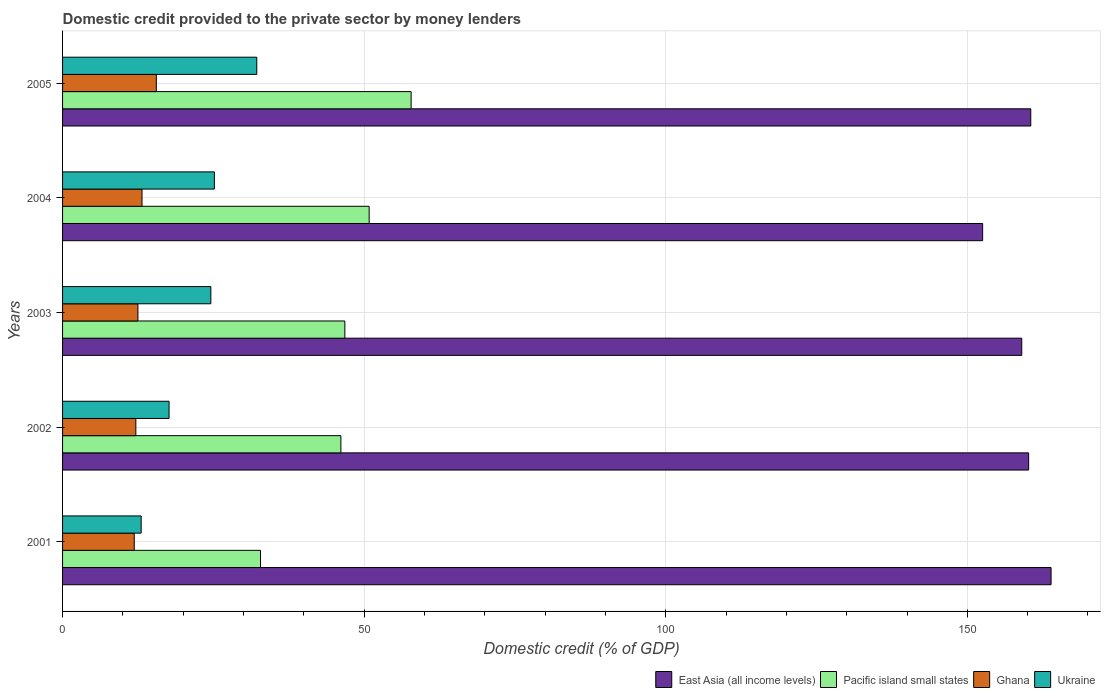How many different coloured bars are there?
Ensure brevity in your answer.  4. How many groups of bars are there?
Offer a terse response. 5. Are the number of bars per tick equal to the number of legend labels?
Ensure brevity in your answer.  Yes. How many bars are there on the 1st tick from the top?
Offer a very short reply. 4. How many bars are there on the 4th tick from the bottom?
Ensure brevity in your answer.  4. What is the label of the 2nd group of bars from the top?
Provide a short and direct response. 2004. In how many cases, is the number of bars for a given year not equal to the number of legend labels?
Your answer should be very brief. 0. What is the domestic credit provided to the private sector by money lenders in Pacific island small states in 2002?
Offer a terse response. 46.14. Across all years, what is the maximum domestic credit provided to the private sector by money lenders in Ghana?
Ensure brevity in your answer.  15.54. Across all years, what is the minimum domestic credit provided to the private sector by money lenders in Ukraine?
Keep it short and to the point. 13.03. In which year was the domestic credit provided to the private sector by money lenders in Pacific island small states minimum?
Your answer should be compact. 2001. What is the total domestic credit provided to the private sector by money lenders in East Asia (all income levels) in the graph?
Keep it short and to the point. 796.12. What is the difference between the domestic credit provided to the private sector by money lenders in Ghana in 2001 and that in 2005?
Offer a very short reply. -3.66. What is the difference between the domestic credit provided to the private sector by money lenders in Ghana in 2003 and the domestic credit provided to the private sector by money lenders in Ukraine in 2002?
Your answer should be very brief. -5.16. What is the average domestic credit provided to the private sector by money lenders in Ghana per year?
Make the answer very short. 13.05. In the year 2002, what is the difference between the domestic credit provided to the private sector by money lenders in Ukraine and domestic credit provided to the private sector by money lenders in Ghana?
Make the answer very short. 5.51. What is the ratio of the domestic credit provided to the private sector by money lenders in Ukraine in 2001 to that in 2003?
Your answer should be compact. 0.53. Is the domestic credit provided to the private sector by money lenders in Pacific island small states in 2002 less than that in 2004?
Keep it short and to the point. Yes. What is the difference between the highest and the second highest domestic credit provided to the private sector by money lenders in Ghana?
Offer a terse response. 2.37. What is the difference between the highest and the lowest domestic credit provided to the private sector by money lenders in Ghana?
Offer a terse response. 3.66. In how many years, is the domestic credit provided to the private sector by money lenders in Pacific island small states greater than the average domestic credit provided to the private sector by money lenders in Pacific island small states taken over all years?
Your response must be concise. 2. Is it the case that in every year, the sum of the domestic credit provided to the private sector by money lenders in East Asia (all income levels) and domestic credit provided to the private sector by money lenders in Pacific island small states is greater than the sum of domestic credit provided to the private sector by money lenders in Ukraine and domestic credit provided to the private sector by money lenders in Ghana?
Provide a succinct answer. Yes. What does the 4th bar from the top in 2003 represents?
Offer a very short reply. East Asia (all income levels). What does the 1st bar from the bottom in 2003 represents?
Your answer should be very brief. East Asia (all income levels). Is it the case that in every year, the sum of the domestic credit provided to the private sector by money lenders in Pacific island small states and domestic credit provided to the private sector by money lenders in East Asia (all income levels) is greater than the domestic credit provided to the private sector by money lenders in Ghana?
Make the answer very short. Yes. How many bars are there?
Give a very brief answer. 20. Are the values on the major ticks of X-axis written in scientific E-notation?
Give a very brief answer. No. Does the graph contain any zero values?
Offer a very short reply. No. Where does the legend appear in the graph?
Provide a short and direct response. Bottom right. How many legend labels are there?
Provide a short and direct response. 4. How are the legend labels stacked?
Provide a short and direct response. Horizontal. What is the title of the graph?
Make the answer very short. Domestic credit provided to the private sector by money lenders. What is the label or title of the X-axis?
Your answer should be very brief. Domestic credit (% of GDP). What is the Domestic credit (% of GDP) of East Asia (all income levels) in 2001?
Provide a short and direct response. 163.88. What is the Domestic credit (% of GDP) of Pacific island small states in 2001?
Ensure brevity in your answer.  32.81. What is the Domestic credit (% of GDP) in Ghana in 2001?
Give a very brief answer. 11.88. What is the Domestic credit (% of GDP) of Ukraine in 2001?
Your response must be concise. 13.03. What is the Domestic credit (% of GDP) of East Asia (all income levels) in 2002?
Your answer should be very brief. 160.16. What is the Domestic credit (% of GDP) in Pacific island small states in 2002?
Your answer should be compact. 46.14. What is the Domestic credit (% of GDP) in Ghana in 2002?
Your answer should be very brief. 12.15. What is the Domestic credit (% of GDP) in Ukraine in 2002?
Your response must be concise. 17.65. What is the Domestic credit (% of GDP) of East Asia (all income levels) in 2003?
Ensure brevity in your answer.  159.02. What is the Domestic credit (% of GDP) of Pacific island small states in 2003?
Your response must be concise. 46.8. What is the Domestic credit (% of GDP) of Ghana in 2003?
Make the answer very short. 12.49. What is the Domestic credit (% of GDP) in Ukraine in 2003?
Ensure brevity in your answer.  24.58. What is the Domestic credit (% of GDP) of East Asia (all income levels) in 2004?
Provide a succinct answer. 152.54. What is the Domestic credit (% of GDP) in Pacific island small states in 2004?
Offer a terse response. 50.83. What is the Domestic credit (% of GDP) in Ghana in 2004?
Offer a terse response. 13.17. What is the Domestic credit (% of GDP) of Ukraine in 2004?
Provide a short and direct response. 25.17. What is the Domestic credit (% of GDP) of East Asia (all income levels) in 2005?
Your response must be concise. 160.51. What is the Domestic credit (% of GDP) in Pacific island small states in 2005?
Your answer should be compact. 57.79. What is the Domestic credit (% of GDP) in Ghana in 2005?
Your answer should be compact. 15.54. What is the Domestic credit (% of GDP) in Ukraine in 2005?
Give a very brief answer. 32.2. Across all years, what is the maximum Domestic credit (% of GDP) of East Asia (all income levels)?
Provide a succinct answer. 163.88. Across all years, what is the maximum Domestic credit (% of GDP) in Pacific island small states?
Make the answer very short. 57.79. Across all years, what is the maximum Domestic credit (% of GDP) in Ghana?
Provide a succinct answer. 15.54. Across all years, what is the maximum Domestic credit (% of GDP) in Ukraine?
Give a very brief answer. 32.2. Across all years, what is the minimum Domestic credit (% of GDP) of East Asia (all income levels)?
Provide a succinct answer. 152.54. Across all years, what is the minimum Domestic credit (% of GDP) in Pacific island small states?
Give a very brief answer. 32.81. Across all years, what is the minimum Domestic credit (% of GDP) in Ghana?
Your response must be concise. 11.88. Across all years, what is the minimum Domestic credit (% of GDP) of Ukraine?
Provide a short and direct response. 13.03. What is the total Domestic credit (% of GDP) in East Asia (all income levels) in the graph?
Provide a succinct answer. 796.12. What is the total Domestic credit (% of GDP) of Pacific island small states in the graph?
Your answer should be very brief. 234.37. What is the total Domestic credit (% of GDP) of Ghana in the graph?
Your response must be concise. 65.24. What is the total Domestic credit (% of GDP) of Ukraine in the graph?
Offer a very short reply. 112.63. What is the difference between the Domestic credit (% of GDP) in East Asia (all income levels) in 2001 and that in 2002?
Give a very brief answer. 3.72. What is the difference between the Domestic credit (% of GDP) of Pacific island small states in 2001 and that in 2002?
Your answer should be compact. -13.33. What is the difference between the Domestic credit (% of GDP) of Ghana in 2001 and that in 2002?
Your response must be concise. -0.27. What is the difference between the Domestic credit (% of GDP) in Ukraine in 2001 and that in 2002?
Make the answer very short. -4.63. What is the difference between the Domestic credit (% of GDP) of East Asia (all income levels) in 2001 and that in 2003?
Provide a succinct answer. 4.86. What is the difference between the Domestic credit (% of GDP) of Pacific island small states in 2001 and that in 2003?
Make the answer very short. -13.98. What is the difference between the Domestic credit (% of GDP) in Ghana in 2001 and that in 2003?
Your answer should be very brief. -0.61. What is the difference between the Domestic credit (% of GDP) in Ukraine in 2001 and that in 2003?
Your response must be concise. -11.55. What is the difference between the Domestic credit (% of GDP) in East Asia (all income levels) in 2001 and that in 2004?
Your response must be concise. 11.34. What is the difference between the Domestic credit (% of GDP) in Pacific island small states in 2001 and that in 2004?
Ensure brevity in your answer.  -18.01. What is the difference between the Domestic credit (% of GDP) in Ghana in 2001 and that in 2004?
Offer a very short reply. -1.29. What is the difference between the Domestic credit (% of GDP) of Ukraine in 2001 and that in 2004?
Give a very brief answer. -12.14. What is the difference between the Domestic credit (% of GDP) of East Asia (all income levels) in 2001 and that in 2005?
Offer a very short reply. 3.37. What is the difference between the Domestic credit (% of GDP) in Pacific island small states in 2001 and that in 2005?
Provide a short and direct response. -24.97. What is the difference between the Domestic credit (% of GDP) in Ghana in 2001 and that in 2005?
Offer a very short reply. -3.66. What is the difference between the Domestic credit (% of GDP) in Ukraine in 2001 and that in 2005?
Offer a terse response. -19.17. What is the difference between the Domestic credit (% of GDP) of East Asia (all income levels) in 2002 and that in 2003?
Offer a very short reply. 1.14. What is the difference between the Domestic credit (% of GDP) in Pacific island small states in 2002 and that in 2003?
Offer a terse response. -0.65. What is the difference between the Domestic credit (% of GDP) of Ghana in 2002 and that in 2003?
Your response must be concise. -0.34. What is the difference between the Domestic credit (% of GDP) of Ukraine in 2002 and that in 2003?
Provide a succinct answer. -6.93. What is the difference between the Domestic credit (% of GDP) in East Asia (all income levels) in 2002 and that in 2004?
Offer a terse response. 7.63. What is the difference between the Domestic credit (% of GDP) in Pacific island small states in 2002 and that in 2004?
Offer a terse response. -4.69. What is the difference between the Domestic credit (% of GDP) of Ghana in 2002 and that in 2004?
Provide a short and direct response. -1.02. What is the difference between the Domestic credit (% of GDP) of Ukraine in 2002 and that in 2004?
Offer a terse response. -7.51. What is the difference between the Domestic credit (% of GDP) in East Asia (all income levels) in 2002 and that in 2005?
Offer a terse response. -0.35. What is the difference between the Domestic credit (% of GDP) in Pacific island small states in 2002 and that in 2005?
Your answer should be very brief. -11.64. What is the difference between the Domestic credit (% of GDP) in Ghana in 2002 and that in 2005?
Keep it short and to the point. -3.39. What is the difference between the Domestic credit (% of GDP) in Ukraine in 2002 and that in 2005?
Offer a very short reply. -14.54. What is the difference between the Domestic credit (% of GDP) of East Asia (all income levels) in 2003 and that in 2004?
Your answer should be very brief. 6.48. What is the difference between the Domestic credit (% of GDP) in Pacific island small states in 2003 and that in 2004?
Your answer should be very brief. -4.03. What is the difference between the Domestic credit (% of GDP) in Ghana in 2003 and that in 2004?
Your answer should be compact. -0.68. What is the difference between the Domestic credit (% of GDP) in Ukraine in 2003 and that in 2004?
Your answer should be compact. -0.58. What is the difference between the Domestic credit (% of GDP) of East Asia (all income levels) in 2003 and that in 2005?
Your response must be concise. -1.49. What is the difference between the Domestic credit (% of GDP) of Pacific island small states in 2003 and that in 2005?
Offer a very short reply. -10.99. What is the difference between the Domestic credit (% of GDP) of Ghana in 2003 and that in 2005?
Give a very brief answer. -3.05. What is the difference between the Domestic credit (% of GDP) of Ukraine in 2003 and that in 2005?
Keep it short and to the point. -7.61. What is the difference between the Domestic credit (% of GDP) in East Asia (all income levels) in 2004 and that in 2005?
Make the answer very short. -7.98. What is the difference between the Domestic credit (% of GDP) in Pacific island small states in 2004 and that in 2005?
Your answer should be very brief. -6.96. What is the difference between the Domestic credit (% of GDP) of Ghana in 2004 and that in 2005?
Keep it short and to the point. -2.37. What is the difference between the Domestic credit (% of GDP) in Ukraine in 2004 and that in 2005?
Provide a succinct answer. -7.03. What is the difference between the Domestic credit (% of GDP) in East Asia (all income levels) in 2001 and the Domestic credit (% of GDP) in Pacific island small states in 2002?
Give a very brief answer. 117.74. What is the difference between the Domestic credit (% of GDP) in East Asia (all income levels) in 2001 and the Domestic credit (% of GDP) in Ghana in 2002?
Provide a short and direct response. 151.73. What is the difference between the Domestic credit (% of GDP) in East Asia (all income levels) in 2001 and the Domestic credit (% of GDP) in Ukraine in 2002?
Provide a succinct answer. 146.23. What is the difference between the Domestic credit (% of GDP) in Pacific island small states in 2001 and the Domestic credit (% of GDP) in Ghana in 2002?
Your response must be concise. 20.66. What is the difference between the Domestic credit (% of GDP) in Pacific island small states in 2001 and the Domestic credit (% of GDP) in Ukraine in 2002?
Give a very brief answer. 15.16. What is the difference between the Domestic credit (% of GDP) in Ghana in 2001 and the Domestic credit (% of GDP) in Ukraine in 2002?
Provide a short and direct response. -5.77. What is the difference between the Domestic credit (% of GDP) in East Asia (all income levels) in 2001 and the Domestic credit (% of GDP) in Pacific island small states in 2003?
Give a very brief answer. 117.08. What is the difference between the Domestic credit (% of GDP) in East Asia (all income levels) in 2001 and the Domestic credit (% of GDP) in Ghana in 2003?
Keep it short and to the point. 151.39. What is the difference between the Domestic credit (% of GDP) in East Asia (all income levels) in 2001 and the Domestic credit (% of GDP) in Ukraine in 2003?
Give a very brief answer. 139.3. What is the difference between the Domestic credit (% of GDP) in Pacific island small states in 2001 and the Domestic credit (% of GDP) in Ghana in 2003?
Give a very brief answer. 20.32. What is the difference between the Domestic credit (% of GDP) in Pacific island small states in 2001 and the Domestic credit (% of GDP) in Ukraine in 2003?
Your response must be concise. 8.23. What is the difference between the Domestic credit (% of GDP) of Ghana in 2001 and the Domestic credit (% of GDP) of Ukraine in 2003?
Your response must be concise. -12.7. What is the difference between the Domestic credit (% of GDP) in East Asia (all income levels) in 2001 and the Domestic credit (% of GDP) in Pacific island small states in 2004?
Give a very brief answer. 113.05. What is the difference between the Domestic credit (% of GDP) of East Asia (all income levels) in 2001 and the Domestic credit (% of GDP) of Ghana in 2004?
Provide a succinct answer. 150.71. What is the difference between the Domestic credit (% of GDP) of East Asia (all income levels) in 2001 and the Domestic credit (% of GDP) of Ukraine in 2004?
Ensure brevity in your answer.  138.71. What is the difference between the Domestic credit (% of GDP) in Pacific island small states in 2001 and the Domestic credit (% of GDP) in Ghana in 2004?
Make the answer very short. 19.64. What is the difference between the Domestic credit (% of GDP) in Pacific island small states in 2001 and the Domestic credit (% of GDP) in Ukraine in 2004?
Offer a very short reply. 7.65. What is the difference between the Domestic credit (% of GDP) in Ghana in 2001 and the Domestic credit (% of GDP) in Ukraine in 2004?
Provide a short and direct response. -13.28. What is the difference between the Domestic credit (% of GDP) of East Asia (all income levels) in 2001 and the Domestic credit (% of GDP) of Pacific island small states in 2005?
Provide a succinct answer. 106.09. What is the difference between the Domestic credit (% of GDP) in East Asia (all income levels) in 2001 and the Domestic credit (% of GDP) in Ghana in 2005?
Offer a terse response. 148.34. What is the difference between the Domestic credit (% of GDP) of East Asia (all income levels) in 2001 and the Domestic credit (% of GDP) of Ukraine in 2005?
Give a very brief answer. 131.68. What is the difference between the Domestic credit (% of GDP) of Pacific island small states in 2001 and the Domestic credit (% of GDP) of Ghana in 2005?
Your answer should be compact. 17.27. What is the difference between the Domestic credit (% of GDP) of Pacific island small states in 2001 and the Domestic credit (% of GDP) of Ukraine in 2005?
Provide a succinct answer. 0.62. What is the difference between the Domestic credit (% of GDP) in Ghana in 2001 and the Domestic credit (% of GDP) in Ukraine in 2005?
Keep it short and to the point. -20.31. What is the difference between the Domestic credit (% of GDP) of East Asia (all income levels) in 2002 and the Domestic credit (% of GDP) of Pacific island small states in 2003?
Keep it short and to the point. 113.37. What is the difference between the Domestic credit (% of GDP) in East Asia (all income levels) in 2002 and the Domestic credit (% of GDP) in Ghana in 2003?
Provide a succinct answer. 147.67. What is the difference between the Domestic credit (% of GDP) in East Asia (all income levels) in 2002 and the Domestic credit (% of GDP) in Ukraine in 2003?
Provide a short and direct response. 135.58. What is the difference between the Domestic credit (% of GDP) of Pacific island small states in 2002 and the Domestic credit (% of GDP) of Ghana in 2003?
Provide a succinct answer. 33.65. What is the difference between the Domestic credit (% of GDP) of Pacific island small states in 2002 and the Domestic credit (% of GDP) of Ukraine in 2003?
Your response must be concise. 21.56. What is the difference between the Domestic credit (% of GDP) in Ghana in 2002 and the Domestic credit (% of GDP) in Ukraine in 2003?
Make the answer very short. -12.43. What is the difference between the Domestic credit (% of GDP) in East Asia (all income levels) in 2002 and the Domestic credit (% of GDP) in Pacific island small states in 2004?
Ensure brevity in your answer.  109.33. What is the difference between the Domestic credit (% of GDP) of East Asia (all income levels) in 2002 and the Domestic credit (% of GDP) of Ghana in 2004?
Your answer should be very brief. 146.99. What is the difference between the Domestic credit (% of GDP) of East Asia (all income levels) in 2002 and the Domestic credit (% of GDP) of Ukraine in 2004?
Give a very brief answer. 135. What is the difference between the Domestic credit (% of GDP) of Pacific island small states in 2002 and the Domestic credit (% of GDP) of Ghana in 2004?
Offer a terse response. 32.97. What is the difference between the Domestic credit (% of GDP) in Pacific island small states in 2002 and the Domestic credit (% of GDP) in Ukraine in 2004?
Offer a terse response. 20.98. What is the difference between the Domestic credit (% of GDP) of Ghana in 2002 and the Domestic credit (% of GDP) of Ukraine in 2004?
Offer a terse response. -13.02. What is the difference between the Domestic credit (% of GDP) in East Asia (all income levels) in 2002 and the Domestic credit (% of GDP) in Pacific island small states in 2005?
Your answer should be compact. 102.38. What is the difference between the Domestic credit (% of GDP) of East Asia (all income levels) in 2002 and the Domestic credit (% of GDP) of Ghana in 2005?
Provide a short and direct response. 144.62. What is the difference between the Domestic credit (% of GDP) of East Asia (all income levels) in 2002 and the Domestic credit (% of GDP) of Ukraine in 2005?
Keep it short and to the point. 127.97. What is the difference between the Domestic credit (% of GDP) of Pacific island small states in 2002 and the Domestic credit (% of GDP) of Ghana in 2005?
Give a very brief answer. 30.6. What is the difference between the Domestic credit (% of GDP) of Pacific island small states in 2002 and the Domestic credit (% of GDP) of Ukraine in 2005?
Ensure brevity in your answer.  13.95. What is the difference between the Domestic credit (% of GDP) of Ghana in 2002 and the Domestic credit (% of GDP) of Ukraine in 2005?
Ensure brevity in your answer.  -20.05. What is the difference between the Domestic credit (% of GDP) in East Asia (all income levels) in 2003 and the Domestic credit (% of GDP) in Pacific island small states in 2004?
Your response must be concise. 108.19. What is the difference between the Domestic credit (% of GDP) of East Asia (all income levels) in 2003 and the Domestic credit (% of GDP) of Ghana in 2004?
Keep it short and to the point. 145.85. What is the difference between the Domestic credit (% of GDP) in East Asia (all income levels) in 2003 and the Domestic credit (% of GDP) in Ukraine in 2004?
Offer a terse response. 133.85. What is the difference between the Domestic credit (% of GDP) of Pacific island small states in 2003 and the Domestic credit (% of GDP) of Ghana in 2004?
Make the answer very short. 33.62. What is the difference between the Domestic credit (% of GDP) of Pacific island small states in 2003 and the Domestic credit (% of GDP) of Ukraine in 2004?
Give a very brief answer. 21.63. What is the difference between the Domestic credit (% of GDP) of Ghana in 2003 and the Domestic credit (% of GDP) of Ukraine in 2004?
Make the answer very short. -12.67. What is the difference between the Domestic credit (% of GDP) of East Asia (all income levels) in 2003 and the Domestic credit (% of GDP) of Pacific island small states in 2005?
Your answer should be compact. 101.23. What is the difference between the Domestic credit (% of GDP) of East Asia (all income levels) in 2003 and the Domestic credit (% of GDP) of Ghana in 2005?
Provide a succinct answer. 143.48. What is the difference between the Domestic credit (% of GDP) of East Asia (all income levels) in 2003 and the Domestic credit (% of GDP) of Ukraine in 2005?
Ensure brevity in your answer.  126.82. What is the difference between the Domestic credit (% of GDP) of Pacific island small states in 2003 and the Domestic credit (% of GDP) of Ghana in 2005?
Make the answer very short. 31.25. What is the difference between the Domestic credit (% of GDP) of Pacific island small states in 2003 and the Domestic credit (% of GDP) of Ukraine in 2005?
Your answer should be compact. 14.6. What is the difference between the Domestic credit (% of GDP) in Ghana in 2003 and the Domestic credit (% of GDP) in Ukraine in 2005?
Give a very brief answer. -19.7. What is the difference between the Domestic credit (% of GDP) in East Asia (all income levels) in 2004 and the Domestic credit (% of GDP) in Pacific island small states in 2005?
Ensure brevity in your answer.  94.75. What is the difference between the Domestic credit (% of GDP) of East Asia (all income levels) in 2004 and the Domestic credit (% of GDP) of Ghana in 2005?
Offer a terse response. 136.99. What is the difference between the Domestic credit (% of GDP) in East Asia (all income levels) in 2004 and the Domestic credit (% of GDP) in Ukraine in 2005?
Provide a short and direct response. 120.34. What is the difference between the Domestic credit (% of GDP) in Pacific island small states in 2004 and the Domestic credit (% of GDP) in Ghana in 2005?
Offer a very short reply. 35.28. What is the difference between the Domestic credit (% of GDP) of Pacific island small states in 2004 and the Domestic credit (% of GDP) of Ukraine in 2005?
Offer a terse response. 18.63. What is the difference between the Domestic credit (% of GDP) in Ghana in 2004 and the Domestic credit (% of GDP) in Ukraine in 2005?
Offer a very short reply. -19.02. What is the average Domestic credit (% of GDP) in East Asia (all income levels) per year?
Your answer should be very brief. 159.22. What is the average Domestic credit (% of GDP) of Pacific island small states per year?
Ensure brevity in your answer.  46.87. What is the average Domestic credit (% of GDP) of Ghana per year?
Your response must be concise. 13.05. What is the average Domestic credit (% of GDP) of Ukraine per year?
Ensure brevity in your answer.  22.53. In the year 2001, what is the difference between the Domestic credit (% of GDP) of East Asia (all income levels) and Domestic credit (% of GDP) of Pacific island small states?
Your answer should be very brief. 131.07. In the year 2001, what is the difference between the Domestic credit (% of GDP) in East Asia (all income levels) and Domestic credit (% of GDP) in Ghana?
Provide a succinct answer. 152. In the year 2001, what is the difference between the Domestic credit (% of GDP) in East Asia (all income levels) and Domestic credit (% of GDP) in Ukraine?
Ensure brevity in your answer.  150.85. In the year 2001, what is the difference between the Domestic credit (% of GDP) of Pacific island small states and Domestic credit (% of GDP) of Ghana?
Make the answer very short. 20.93. In the year 2001, what is the difference between the Domestic credit (% of GDP) in Pacific island small states and Domestic credit (% of GDP) in Ukraine?
Provide a short and direct response. 19.78. In the year 2001, what is the difference between the Domestic credit (% of GDP) of Ghana and Domestic credit (% of GDP) of Ukraine?
Your answer should be compact. -1.15. In the year 2002, what is the difference between the Domestic credit (% of GDP) in East Asia (all income levels) and Domestic credit (% of GDP) in Pacific island small states?
Give a very brief answer. 114.02. In the year 2002, what is the difference between the Domestic credit (% of GDP) in East Asia (all income levels) and Domestic credit (% of GDP) in Ghana?
Your answer should be compact. 148.01. In the year 2002, what is the difference between the Domestic credit (% of GDP) of East Asia (all income levels) and Domestic credit (% of GDP) of Ukraine?
Give a very brief answer. 142.51. In the year 2002, what is the difference between the Domestic credit (% of GDP) in Pacific island small states and Domestic credit (% of GDP) in Ghana?
Give a very brief answer. 33.99. In the year 2002, what is the difference between the Domestic credit (% of GDP) in Pacific island small states and Domestic credit (% of GDP) in Ukraine?
Your answer should be compact. 28.49. In the year 2002, what is the difference between the Domestic credit (% of GDP) of Ghana and Domestic credit (% of GDP) of Ukraine?
Offer a very short reply. -5.51. In the year 2003, what is the difference between the Domestic credit (% of GDP) of East Asia (all income levels) and Domestic credit (% of GDP) of Pacific island small states?
Offer a terse response. 112.22. In the year 2003, what is the difference between the Domestic credit (% of GDP) in East Asia (all income levels) and Domestic credit (% of GDP) in Ghana?
Your answer should be compact. 146.53. In the year 2003, what is the difference between the Domestic credit (% of GDP) of East Asia (all income levels) and Domestic credit (% of GDP) of Ukraine?
Make the answer very short. 134.44. In the year 2003, what is the difference between the Domestic credit (% of GDP) in Pacific island small states and Domestic credit (% of GDP) in Ghana?
Your response must be concise. 34.3. In the year 2003, what is the difference between the Domestic credit (% of GDP) in Pacific island small states and Domestic credit (% of GDP) in Ukraine?
Provide a succinct answer. 22.21. In the year 2003, what is the difference between the Domestic credit (% of GDP) in Ghana and Domestic credit (% of GDP) in Ukraine?
Your response must be concise. -12.09. In the year 2004, what is the difference between the Domestic credit (% of GDP) in East Asia (all income levels) and Domestic credit (% of GDP) in Pacific island small states?
Your response must be concise. 101.71. In the year 2004, what is the difference between the Domestic credit (% of GDP) of East Asia (all income levels) and Domestic credit (% of GDP) of Ghana?
Offer a terse response. 139.36. In the year 2004, what is the difference between the Domestic credit (% of GDP) in East Asia (all income levels) and Domestic credit (% of GDP) in Ukraine?
Your answer should be compact. 127.37. In the year 2004, what is the difference between the Domestic credit (% of GDP) of Pacific island small states and Domestic credit (% of GDP) of Ghana?
Keep it short and to the point. 37.66. In the year 2004, what is the difference between the Domestic credit (% of GDP) of Pacific island small states and Domestic credit (% of GDP) of Ukraine?
Your answer should be very brief. 25.66. In the year 2004, what is the difference between the Domestic credit (% of GDP) in Ghana and Domestic credit (% of GDP) in Ukraine?
Offer a very short reply. -11.99. In the year 2005, what is the difference between the Domestic credit (% of GDP) of East Asia (all income levels) and Domestic credit (% of GDP) of Pacific island small states?
Your answer should be very brief. 102.73. In the year 2005, what is the difference between the Domestic credit (% of GDP) of East Asia (all income levels) and Domestic credit (% of GDP) of Ghana?
Your response must be concise. 144.97. In the year 2005, what is the difference between the Domestic credit (% of GDP) in East Asia (all income levels) and Domestic credit (% of GDP) in Ukraine?
Your response must be concise. 128.32. In the year 2005, what is the difference between the Domestic credit (% of GDP) of Pacific island small states and Domestic credit (% of GDP) of Ghana?
Offer a very short reply. 42.24. In the year 2005, what is the difference between the Domestic credit (% of GDP) of Pacific island small states and Domestic credit (% of GDP) of Ukraine?
Give a very brief answer. 25.59. In the year 2005, what is the difference between the Domestic credit (% of GDP) in Ghana and Domestic credit (% of GDP) in Ukraine?
Give a very brief answer. -16.65. What is the ratio of the Domestic credit (% of GDP) in East Asia (all income levels) in 2001 to that in 2002?
Offer a very short reply. 1.02. What is the ratio of the Domestic credit (% of GDP) in Pacific island small states in 2001 to that in 2002?
Your answer should be compact. 0.71. What is the ratio of the Domestic credit (% of GDP) in Ghana in 2001 to that in 2002?
Provide a short and direct response. 0.98. What is the ratio of the Domestic credit (% of GDP) in Ukraine in 2001 to that in 2002?
Your answer should be compact. 0.74. What is the ratio of the Domestic credit (% of GDP) of East Asia (all income levels) in 2001 to that in 2003?
Offer a very short reply. 1.03. What is the ratio of the Domestic credit (% of GDP) in Pacific island small states in 2001 to that in 2003?
Your answer should be compact. 0.7. What is the ratio of the Domestic credit (% of GDP) in Ghana in 2001 to that in 2003?
Offer a very short reply. 0.95. What is the ratio of the Domestic credit (% of GDP) of Ukraine in 2001 to that in 2003?
Your answer should be very brief. 0.53. What is the ratio of the Domestic credit (% of GDP) in East Asia (all income levels) in 2001 to that in 2004?
Provide a short and direct response. 1.07. What is the ratio of the Domestic credit (% of GDP) of Pacific island small states in 2001 to that in 2004?
Give a very brief answer. 0.65. What is the ratio of the Domestic credit (% of GDP) in Ghana in 2001 to that in 2004?
Provide a succinct answer. 0.9. What is the ratio of the Domestic credit (% of GDP) in Ukraine in 2001 to that in 2004?
Provide a succinct answer. 0.52. What is the ratio of the Domestic credit (% of GDP) of Pacific island small states in 2001 to that in 2005?
Keep it short and to the point. 0.57. What is the ratio of the Domestic credit (% of GDP) in Ghana in 2001 to that in 2005?
Provide a succinct answer. 0.76. What is the ratio of the Domestic credit (% of GDP) in Ukraine in 2001 to that in 2005?
Your response must be concise. 0.4. What is the ratio of the Domestic credit (% of GDP) in East Asia (all income levels) in 2002 to that in 2003?
Your answer should be very brief. 1.01. What is the ratio of the Domestic credit (% of GDP) in Ghana in 2002 to that in 2003?
Your answer should be compact. 0.97. What is the ratio of the Domestic credit (% of GDP) of Ukraine in 2002 to that in 2003?
Provide a succinct answer. 0.72. What is the ratio of the Domestic credit (% of GDP) of East Asia (all income levels) in 2002 to that in 2004?
Your answer should be very brief. 1.05. What is the ratio of the Domestic credit (% of GDP) of Pacific island small states in 2002 to that in 2004?
Provide a succinct answer. 0.91. What is the ratio of the Domestic credit (% of GDP) in Ghana in 2002 to that in 2004?
Keep it short and to the point. 0.92. What is the ratio of the Domestic credit (% of GDP) in Ukraine in 2002 to that in 2004?
Your answer should be compact. 0.7. What is the ratio of the Domestic credit (% of GDP) in East Asia (all income levels) in 2002 to that in 2005?
Keep it short and to the point. 1. What is the ratio of the Domestic credit (% of GDP) in Pacific island small states in 2002 to that in 2005?
Your answer should be very brief. 0.8. What is the ratio of the Domestic credit (% of GDP) of Ghana in 2002 to that in 2005?
Provide a short and direct response. 0.78. What is the ratio of the Domestic credit (% of GDP) in Ukraine in 2002 to that in 2005?
Your answer should be compact. 0.55. What is the ratio of the Domestic credit (% of GDP) in East Asia (all income levels) in 2003 to that in 2004?
Provide a succinct answer. 1.04. What is the ratio of the Domestic credit (% of GDP) in Pacific island small states in 2003 to that in 2004?
Provide a succinct answer. 0.92. What is the ratio of the Domestic credit (% of GDP) of Ghana in 2003 to that in 2004?
Keep it short and to the point. 0.95. What is the ratio of the Domestic credit (% of GDP) in Ukraine in 2003 to that in 2004?
Your response must be concise. 0.98. What is the ratio of the Domestic credit (% of GDP) in East Asia (all income levels) in 2003 to that in 2005?
Your response must be concise. 0.99. What is the ratio of the Domestic credit (% of GDP) in Pacific island small states in 2003 to that in 2005?
Provide a short and direct response. 0.81. What is the ratio of the Domestic credit (% of GDP) of Ghana in 2003 to that in 2005?
Keep it short and to the point. 0.8. What is the ratio of the Domestic credit (% of GDP) in Ukraine in 2003 to that in 2005?
Provide a succinct answer. 0.76. What is the ratio of the Domestic credit (% of GDP) in East Asia (all income levels) in 2004 to that in 2005?
Your answer should be very brief. 0.95. What is the ratio of the Domestic credit (% of GDP) of Pacific island small states in 2004 to that in 2005?
Offer a terse response. 0.88. What is the ratio of the Domestic credit (% of GDP) of Ghana in 2004 to that in 2005?
Your response must be concise. 0.85. What is the ratio of the Domestic credit (% of GDP) of Ukraine in 2004 to that in 2005?
Keep it short and to the point. 0.78. What is the difference between the highest and the second highest Domestic credit (% of GDP) of East Asia (all income levels)?
Your answer should be compact. 3.37. What is the difference between the highest and the second highest Domestic credit (% of GDP) in Pacific island small states?
Give a very brief answer. 6.96. What is the difference between the highest and the second highest Domestic credit (% of GDP) in Ghana?
Keep it short and to the point. 2.37. What is the difference between the highest and the second highest Domestic credit (% of GDP) of Ukraine?
Provide a short and direct response. 7.03. What is the difference between the highest and the lowest Domestic credit (% of GDP) in East Asia (all income levels)?
Make the answer very short. 11.34. What is the difference between the highest and the lowest Domestic credit (% of GDP) of Pacific island small states?
Your response must be concise. 24.97. What is the difference between the highest and the lowest Domestic credit (% of GDP) of Ghana?
Your answer should be very brief. 3.66. What is the difference between the highest and the lowest Domestic credit (% of GDP) of Ukraine?
Offer a terse response. 19.17. 